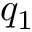<formula> <loc_0><loc_0><loc_500><loc_500>q _ { 1 }</formula> 